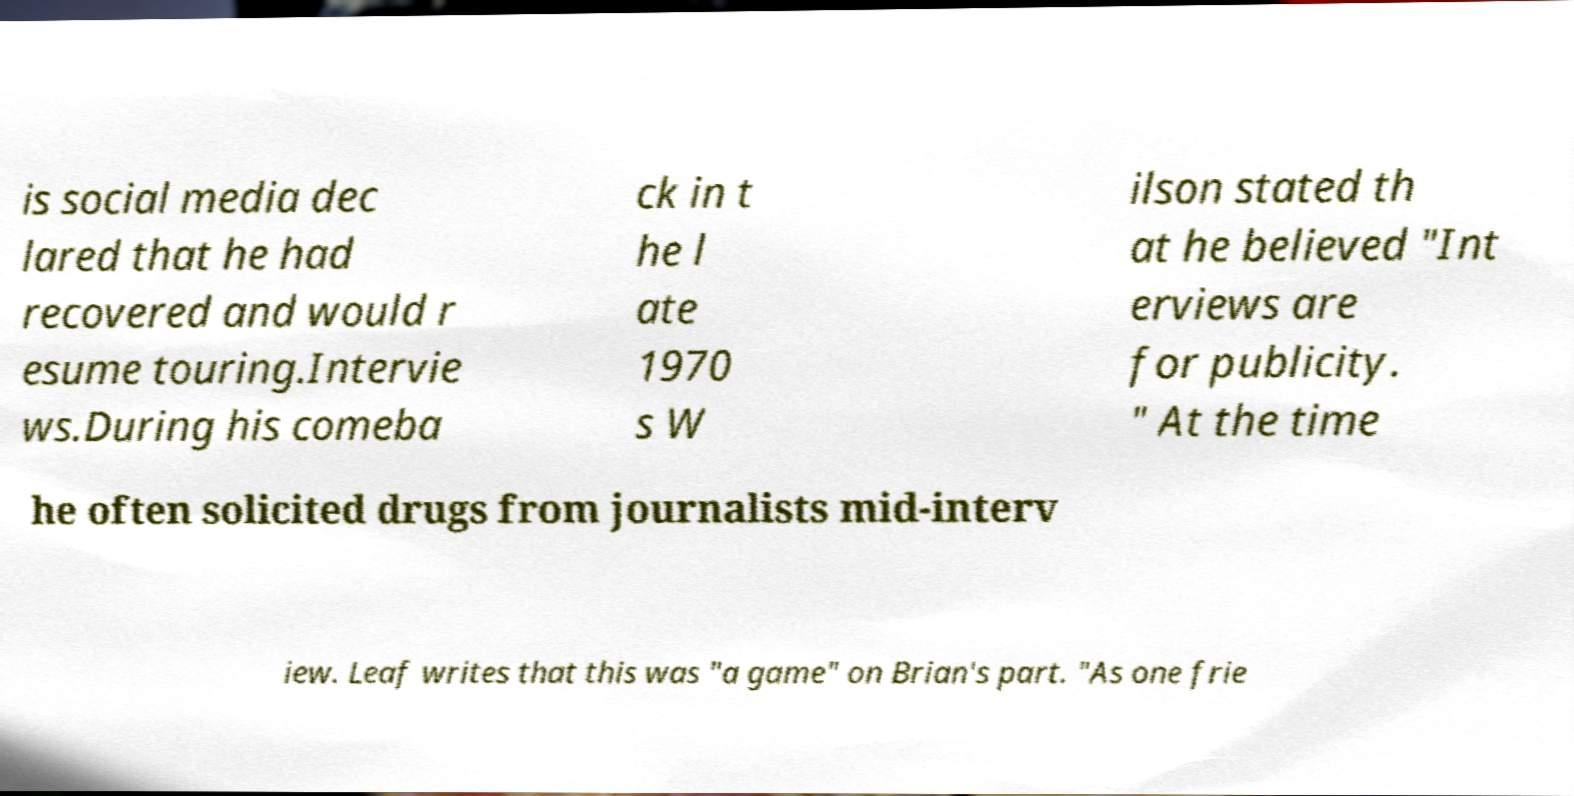I need the written content from this picture converted into text. Can you do that? is social media dec lared that he had recovered and would r esume touring.Intervie ws.During his comeba ck in t he l ate 1970 s W ilson stated th at he believed "Int erviews are for publicity. " At the time he often solicited drugs from journalists mid-interv iew. Leaf writes that this was "a game" on Brian's part. "As one frie 